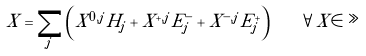<formula> <loc_0><loc_0><loc_500><loc_500>X = \sum _ { j } \left ( X ^ { 0 , j } H _ { j } + X ^ { + , j } E _ { j } ^ { - } + X ^ { - , j } E _ { j } ^ { + } \right ) \quad \forall X \in \gg</formula> 